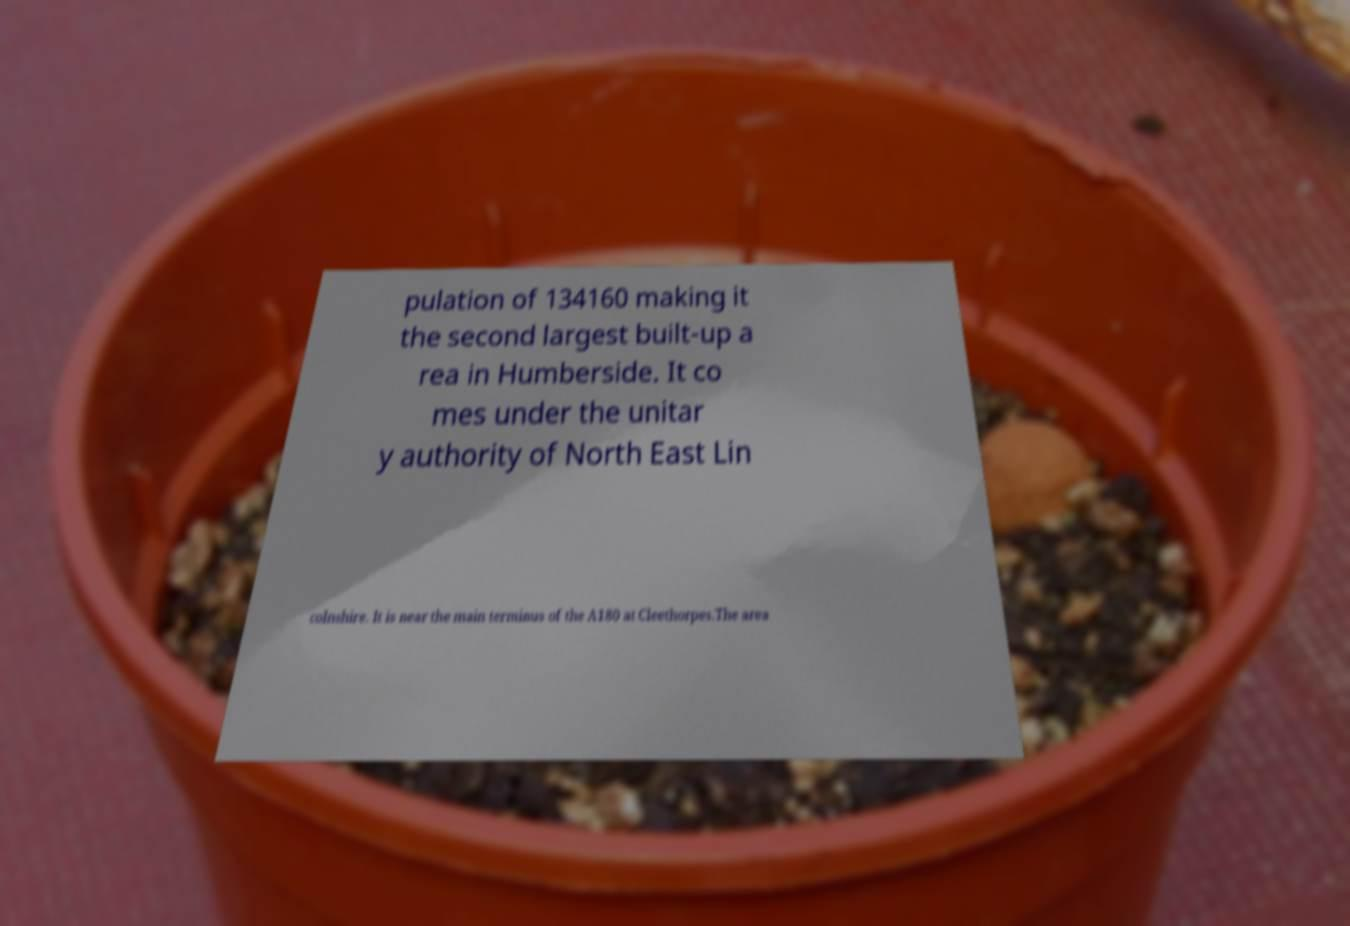Please identify and transcribe the text found in this image. pulation of 134160 making it the second largest built-up a rea in Humberside. It co mes under the unitar y authority of North East Lin colnshire. It is near the main terminus of the A180 at Cleethorpes.The area 